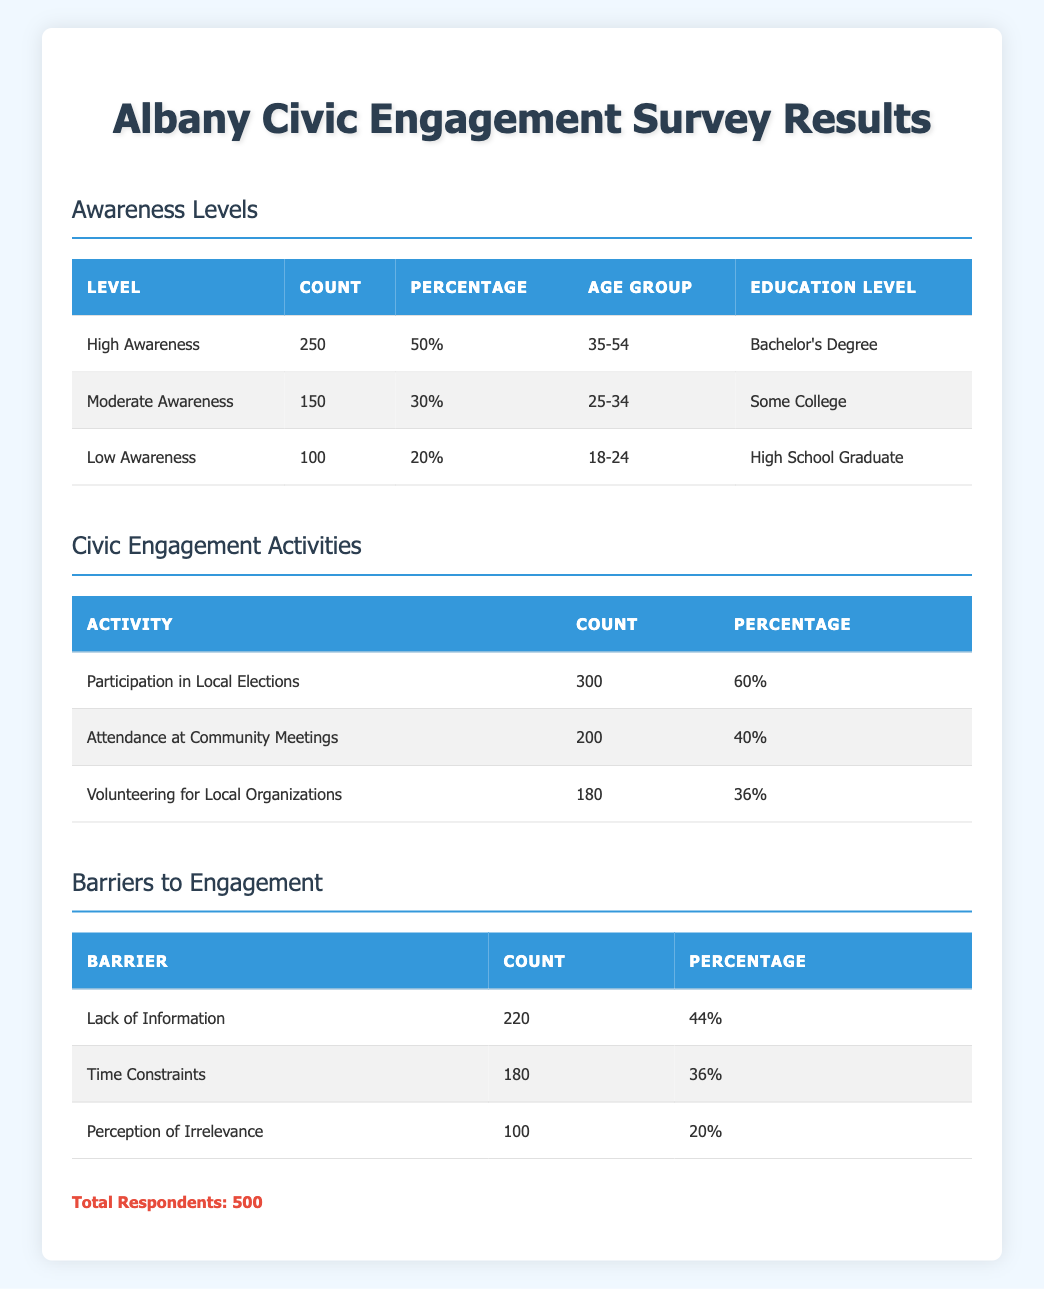What percentage of respondents reported high awareness of civic engagement? According to the table, the "High Awareness" category has 250 respondents, which is equal to 50% of the total 500 respondents.
Answer: 50% What is the count of residents with low awareness? The "Low Awareness" level has a count of 100 respondents as indicated in the table.
Answer: 100 Which civic engagement activity had the highest participation? The activity with the highest participation is "Participation in Local Elections," with a count of 300 respondents, as shown in the respective section of the table.
Answer: 300 What is the total percentage of respondents who attended community meetings and volunteered for local organizations combined? The percentage for "Attendance at Community Meetings" is 40% and for "Volunteering for Local Organizations" is 36%. Therefore, adding these two percentages gives us 40 + 36 = 76%.
Answer: 76% Is it true that more than half of the surveyed residents are engaged in local elections? Yes, the table shows that 300 out of 500 respondents, which is 60%, reported participating in local elections, confirming that it is more than half.
Answer: Yes How many respondents cited time constraints as a barrier to engagement? The table states that 180 respondents mentioned "Time Constraints" as a barrier to engagement.
Answer: 180 What is the combined count of residents who have moderate or low awareness? The count for "Moderate Awareness" is 150 and "Low Awareness" has 100 respondents. Adding these gives us 150 + 100 = 250 combined respondents.
Answer: 250 Which barrier had the least number of respondents mentioning it? The barrier with the least mentions is "Perception of Irrelevance," with a count of 100 respondents, as shown in the barriers section of the table.
Answer: 100 What is the demographic profile of respondents with high awareness? The demographic profile shows that individuals aged 35-54 with a Bachelor's Degree constitute the "High Awareness" level, as noted in the table's demographic details.
Answer: 35-54, Bachelor's Degree How many respondents experienced a lack of information as a barrier? The table indicates that 220 respondents identified "Lack of Information" as a barrier to engagement.
Answer: 220 